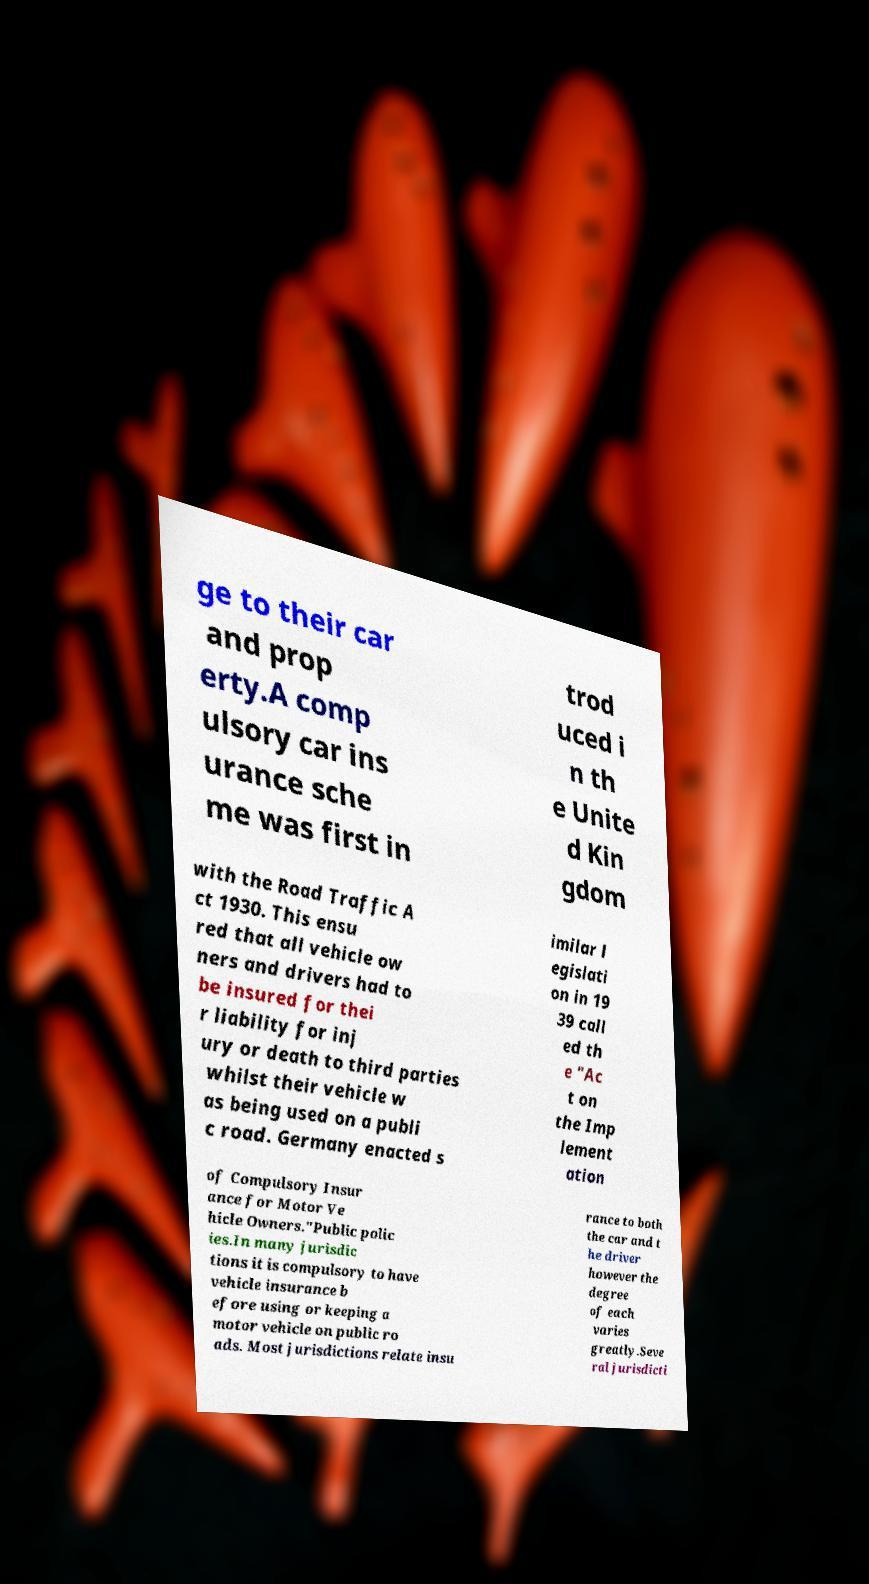I need the written content from this picture converted into text. Can you do that? ge to their car and prop erty.A comp ulsory car ins urance sche me was first in trod uced i n th e Unite d Kin gdom with the Road Traffic A ct 1930. This ensu red that all vehicle ow ners and drivers had to be insured for thei r liability for inj ury or death to third parties whilst their vehicle w as being used on a publi c road. Germany enacted s imilar l egislati on in 19 39 call ed th e "Ac t on the Imp lement ation of Compulsory Insur ance for Motor Ve hicle Owners."Public polic ies.In many jurisdic tions it is compulsory to have vehicle insurance b efore using or keeping a motor vehicle on public ro ads. Most jurisdictions relate insu rance to both the car and t he driver however the degree of each varies greatly.Seve ral jurisdicti 